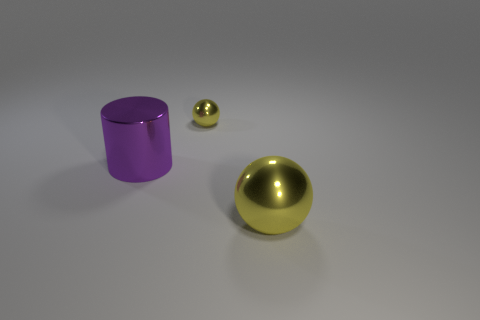The object that is the same color as the large metal sphere is what size?
Offer a very short reply. Small. There is a big shiny thing to the right of the large shiny cylinder; is there a sphere that is behind it?
Ensure brevity in your answer.  Yes. There is a metallic thing that is to the right of the purple metal object and in front of the small metallic thing; what is its color?
Make the answer very short. Yellow. There is a metallic object that is in front of the large thing behind the big shiny sphere; is there a metallic ball that is left of it?
Your response must be concise. Yes. There is another shiny object that is the same shape as the small thing; what size is it?
Keep it short and to the point. Large. Are any yellow objects visible?
Keep it short and to the point. Yes. Do the tiny thing and the metal sphere that is in front of the big metal cylinder have the same color?
Your answer should be compact. Yes. There is a shiny object in front of the big object left of the yellow metal sphere that is in front of the purple cylinder; what is its size?
Your answer should be compact. Large. What number of large balls are the same color as the small metallic ball?
Offer a terse response. 1. What number of things are either large yellow objects or spheres that are behind the big metallic cylinder?
Provide a succinct answer. 2. 